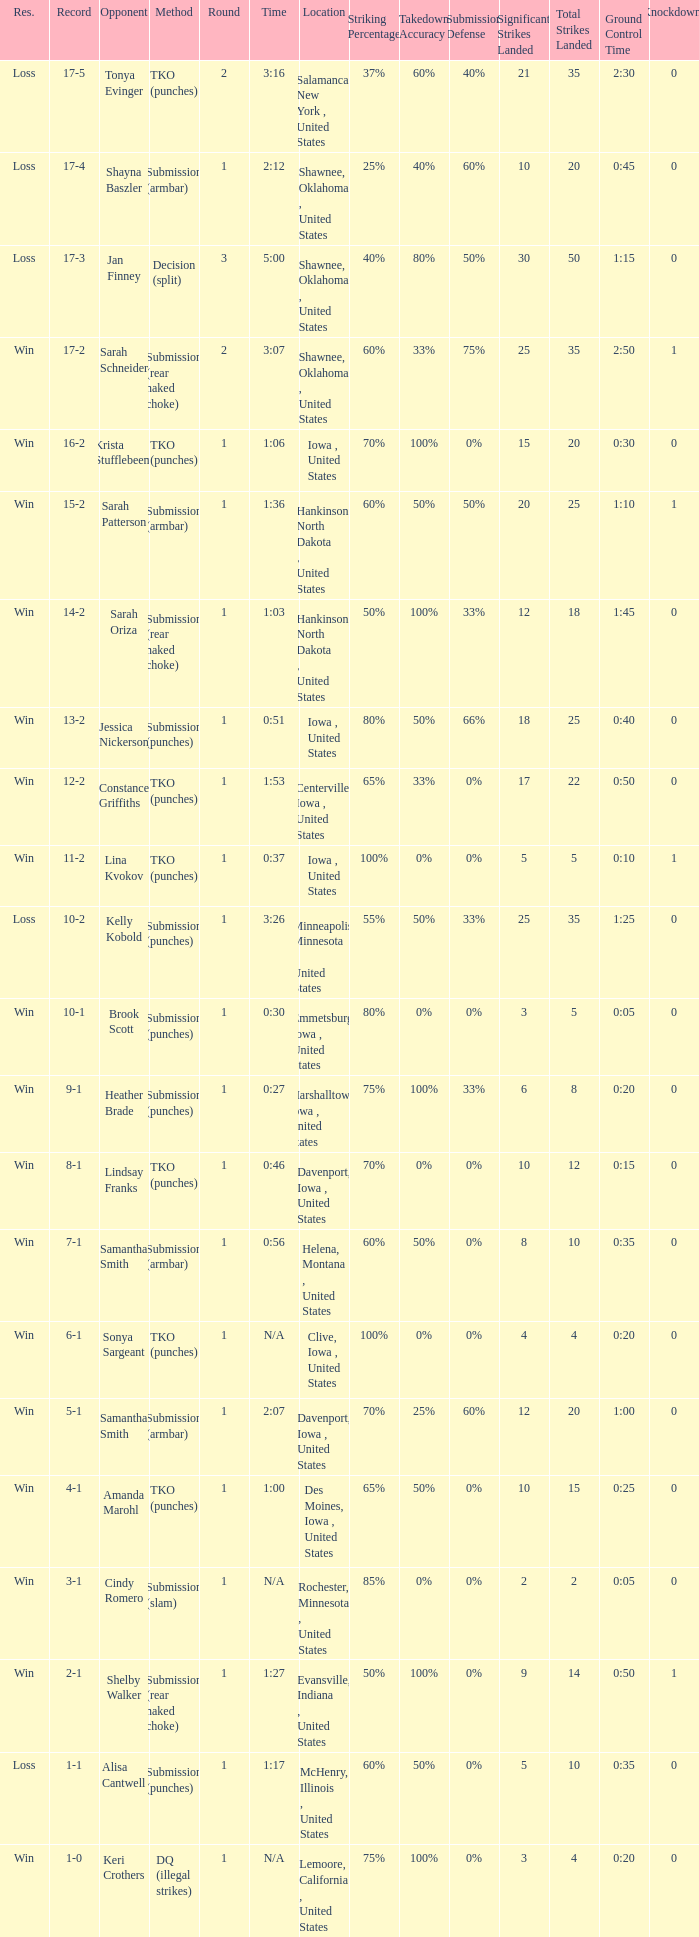What opponent does she fight when she is 10-1? Brook Scott. 